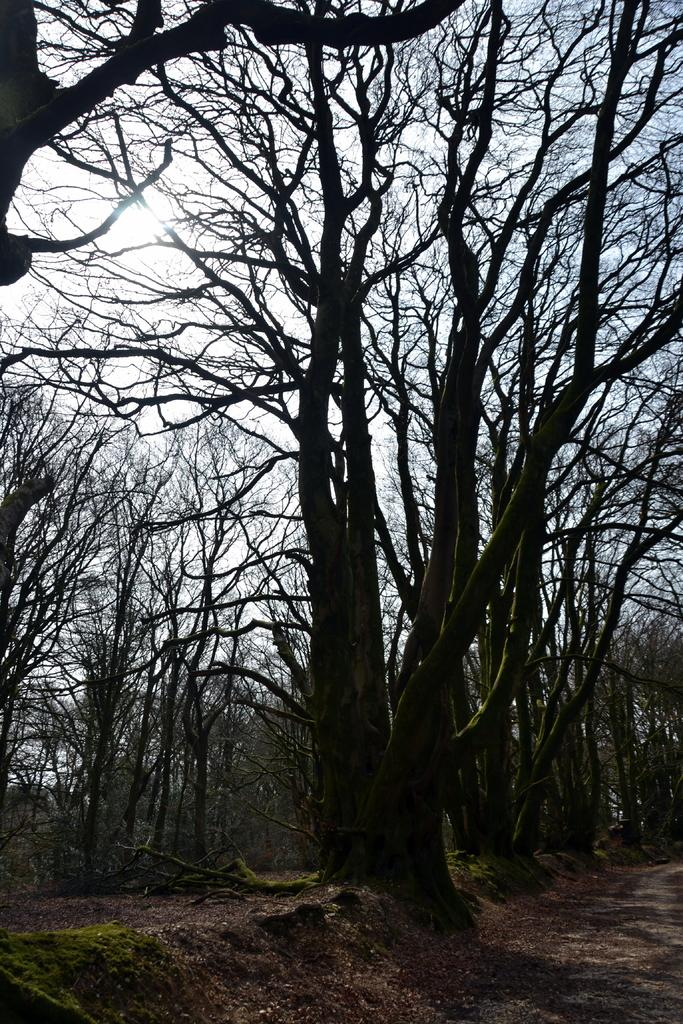What can be seen in the background of the image? The sky is visible in the image. What type of vegetation is present in the image? There are trees in the image. What type of location is depicted in the image? The image depicts a forest area. How does the jar affect the growth of the trees in the image? There is no jar present in the image, so it cannot have any effect on the growth of the trees. 